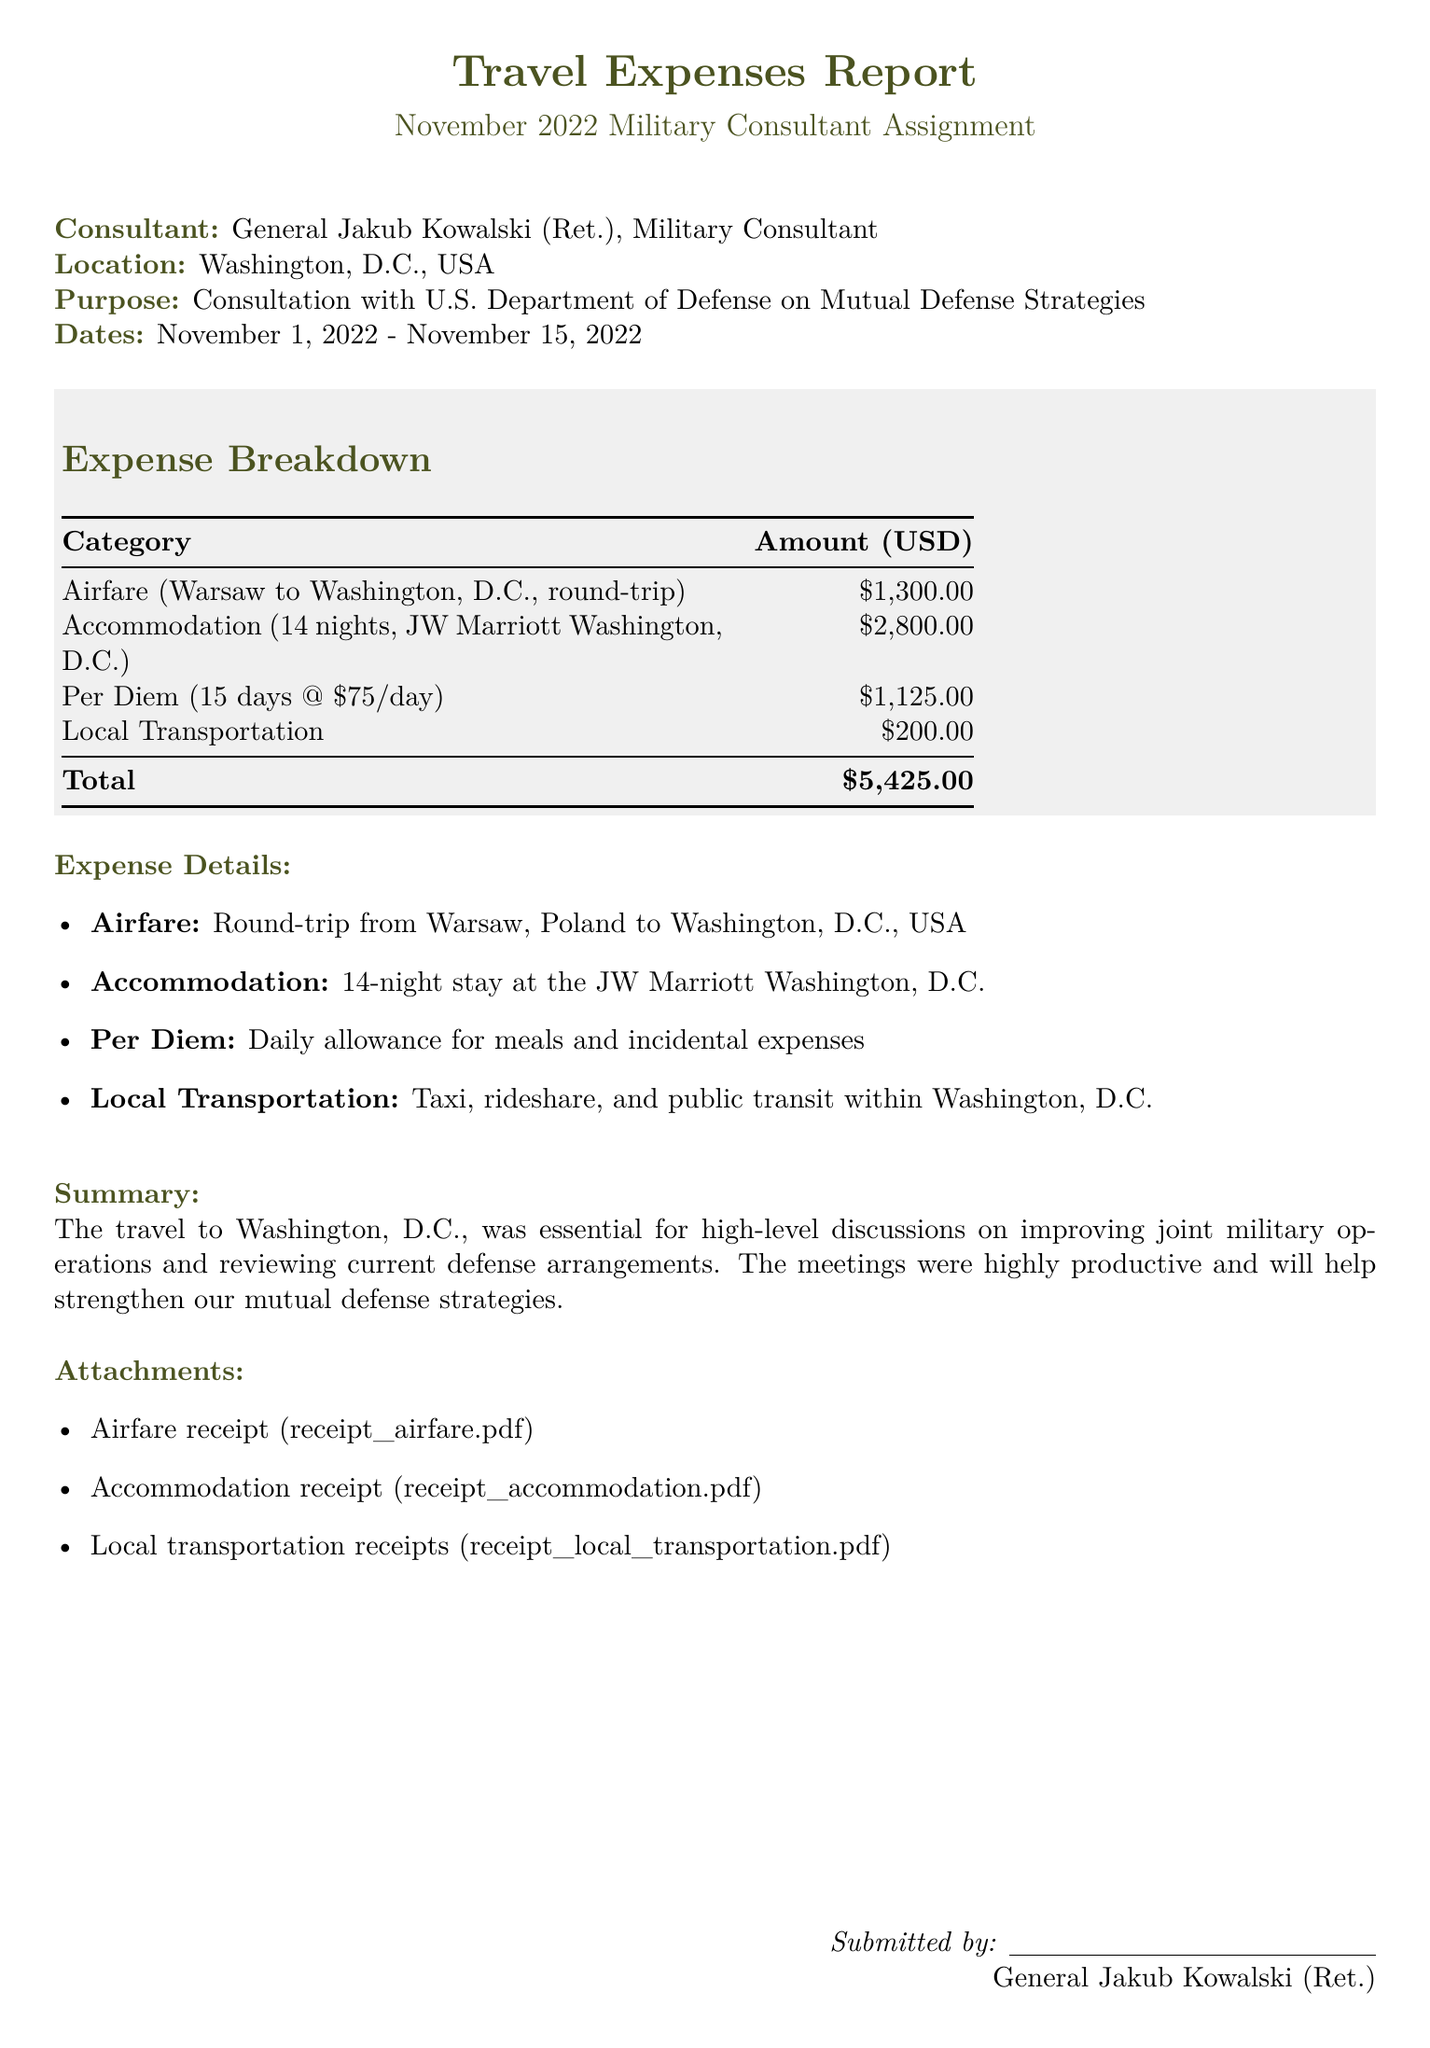What is the total amount of expenses? The total amount of expenses is found in the expense breakdown section, summing up all categories.
Answer: $5,425.00 What was the location of the assignment? The document specifies that the assignment took place in Washington, D.C., USA.
Answer: Washington, D.C., USA How many nights did the consultant stay at the hotel? The accommodation section indicates the number of nights stayed, which is mentioned as 14 nights.
Answer: 14 nights What was the per diem rate per day? The per diem section states the daily allowance for meals and incidental expenses, which is $75 per day.
Answer: $75/day What was the purpose of the trip? The document states the purpose was for consultation with U.S. Department of Defense on Mutual Defense Strategies.
Answer: Consultation with U.S. Department of Defense on Mutual Defense Strategies How many days was the trip? The trip's dates mentioned span from November 1, 2022, to November 15, 2022, indicating the trip lasted 15 days.
Answer: 15 days What type of accommodation was used? The accommodation section specifies that the consultant stayed at the JW Marriott Washington, D.C.
Answer: JW Marriott Washington, D.C What receipt types are included in the attachments? The attachments list identifies the types of receipts included, such as airfare and accommodation receipts.
Answer: Airfare and accommodation receipts What transportation methods were used locally? The local transportation section mentions that various methods like taxi, rideshare, and public transit were used.
Answer: Taxi, rideshare, and public transit 